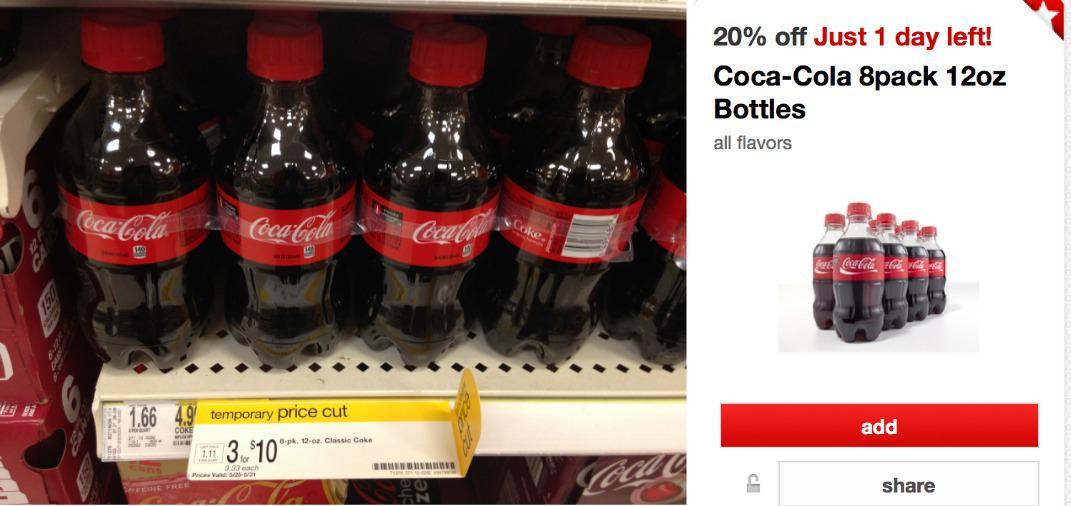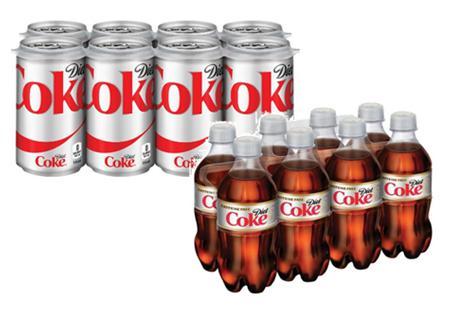The first image is the image on the left, the second image is the image on the right. Evaluate the accuracy of this statement regarding the images: "One of the images has 3 bottles, while the other one has 4.". Is it true? Answer yes or no. No. The first image is the image on the left, the second image is the image on the right. Examine the images to the left and right. Is the description "There are exactly seven bottles." accurate? Answer yes or no. No. 